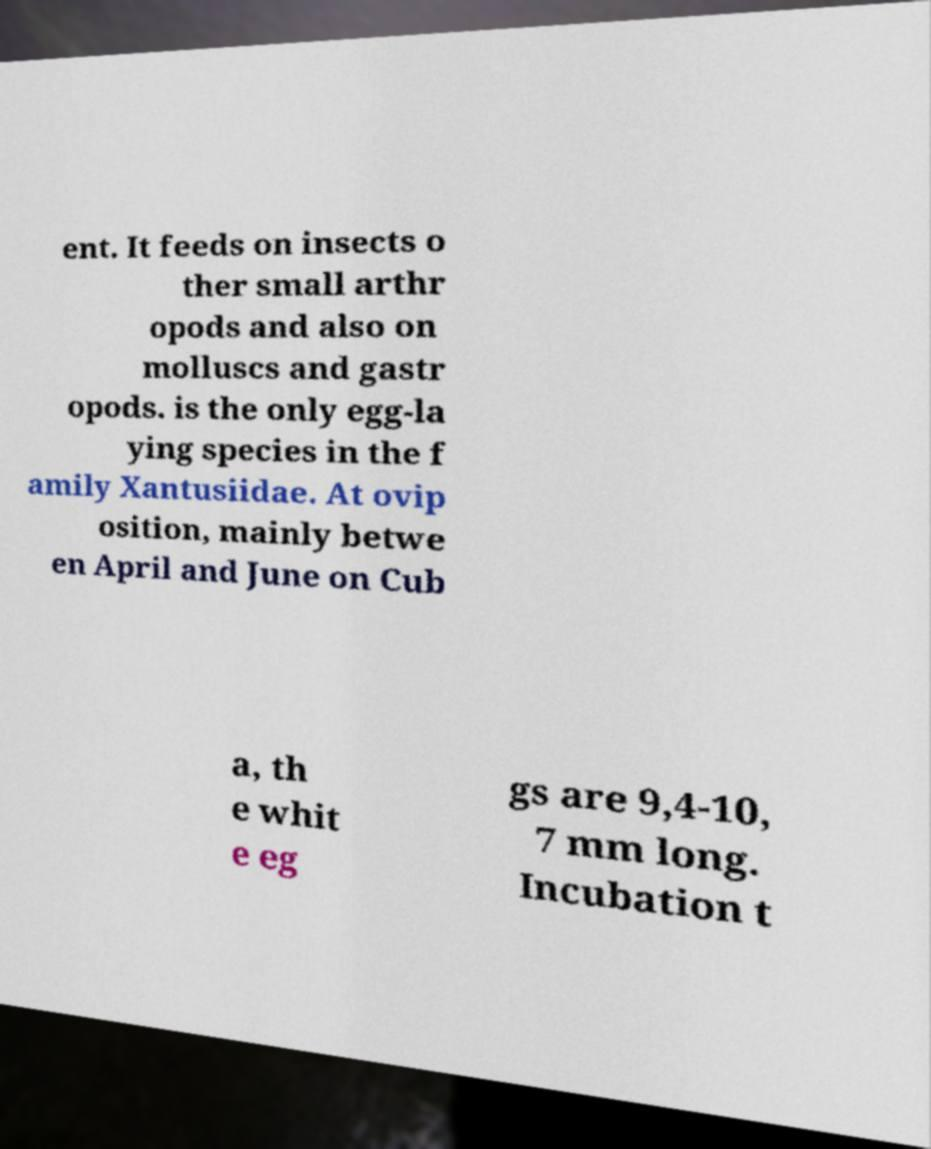There's text embedded in this image that I need extracted. Can you transcribe it verbatim? ent. It feeds on insects o ther small arthr opods and also on molluscs and gastr opods. is the only egg-la ying species in the f amily Xantusiidae. At ovip osition, mainly betwe en April and June on Cub a, th e whit e eg gs are 9,4-10, 7 mm long. Incubation t 